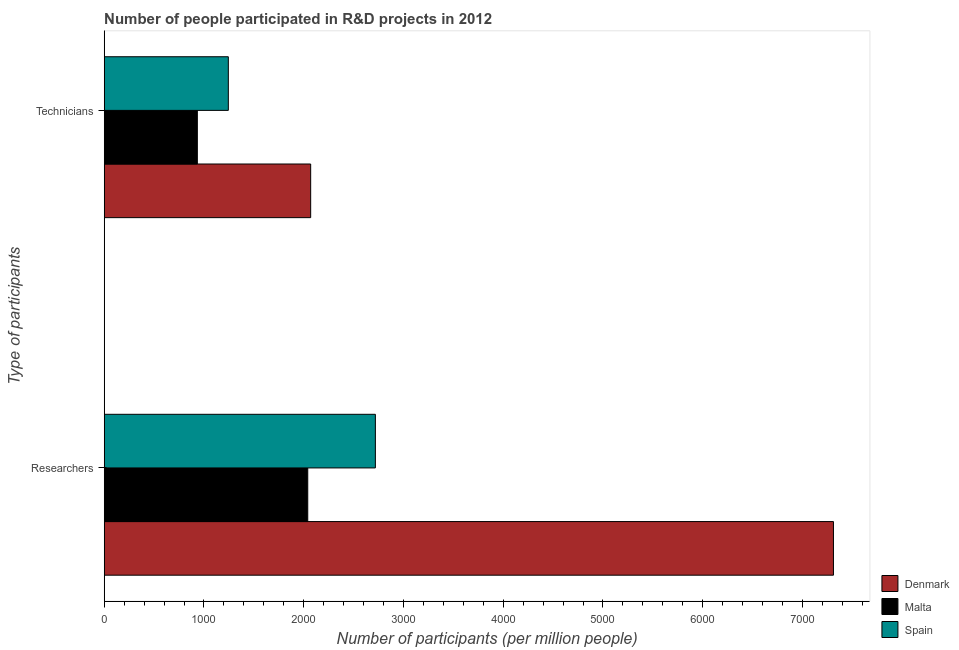How many groups of bars are there?
Offer a terse response. 2. Are the number of bars per tick equal to the number of legend labels?
Give a very brief answer. Yes. How many bars are there on the 1st tick from the bottom?
Give a very brief answer. 3. What is the label of the 2nd group of bars from the top?
Your answer should be compact. Researchers. What is the number of technicians in Spain?
Offer a terse response. 1244.26. Across all countries, what is the maximum number of technicians?
Keep it short and to the point. 2069.7. Across all countries, what is the minimum number of technicians?
Give a very brief answer. 933.6. In which country was the number of technicians maximum?
Your answer should be very brief. Denmark. In which country was the number of researchers minimum?
Keep it short and to the point. Malta. What is the total number of researchers in the graph?
Your answer should be very brief. 1.21e+04. What is the difference between the number of technicians in Spain and that in Malta?
Your answer should be compact. 310.66. What is the difference between the number of researchers in Spain and the number of technicians in Malta?
Offer a terse response. 1784.79. What is the average number of researchers per country?
Your answer should be compact. 4023.11. What is the difference between the number of technicians and number of researchers in Spain?
Keep it short and to the point. -1474.12. In how many countries, is the number of technicians greater than 1400 ?
Your response must be concise. 1. What is the ratio of the number of researchers in Malta to that in Denmark?
Provide a succinct answer. 0.28. What does the 3rd bar from the top in Researchers represents?
Provide a succinct answer. Denmark. What does the 3rd bar from the bottom in Technicians represents?
Provide a short and direct response. Spain. Are all the bars in the graph horizontal?
Provide a succinct answer. Yes. How many countries are there in the graph?
Keep it short and to the point. 3. What is the difference between two consecutive major ticks on the X-axis?
Offer a very short reply. 1000. Does the graph contain grids?
Your answer should be compact. No. Where does the legend appear in the graph?
Ensure brevity in your answer.  Bottom right. How many legend labels are there?
Provide a succinct answer. 3. How are the legend labels stacked?
Offer a very short reply. Vertical. What is the title of the graph?
Give a very brief answer. Number of people participated in R&D projects in 2012. What is the label or title of the X-axis?
Your answer should be compact. Number of participants (per million people). What is the label or title of the Y-axis?
Give a very brief answer. Type of participants. What is the Number of participants (per million people) in Denmark in Researchers?
Provide a short and direct response. 7310.52. What is the Number of participants (per million people) of Malta in Researchers?
Offer a terse response. 2040.44. What is the Number of participants (per million people) in Spain in Researchers?
Make the answer very short. 2718.38. What is the Number of participants (per million people) of Denmark in Technicians?
Give a very brief answer. 2069.7. What is the Number of participants (per million people) of Malta in Technicians?
Give a very brief answer. 933.6. What is the Number of participants (per million people) in Spain in Technicians?
Offer a terse response. 1244.26. Across all Type of participants, what is the maximum Number of participants (per million people) in Denmark?
Provide a short and direct response. 7310.52. Across all Type of participants, what is the maximum Number of participants (per million people) in Malta?
Your answer should be very brief. 2040.44. Across all Type of participants, what is the maximum Number of participants (per million people) in Spain?
Provide a short and direct response. 2718.38. Across all Type of participants, what is the minimum Number of participants (per million people) of Denmark?
Ensure brevity in your answer.  2069.7. Across all Type of participants, what is the minimum Number of participants (per million people) in Malta?
Keep it short and to the point. 933.6. Across all Type of participants, what is the minimum Number of participants (per million people) of Spain?
Offer a very short reply. 1244.26. What is the total Number of participants (per million people) in Denmark in the graph?
Provide a succinct answer. 9380.22. What is the total Number of participants (per million people) of Malta in the graph?
Provide a succinct answer. 2974.04. What is the total Number of participants (per million people) in Spain in the graph?
Your response must be concise. 3962.65. What is the difference between the Number of participants (per million people) in Denmark in Researchers and that in Technicians?
Your answer should be very brief. 5240.81. What is the difference between the Number of participants (per million people) in Malta in Researchers and that in Technicians?
Give a very brief answer. 1106.84. What is the difference between the Number of participants (per million people) in Spain in Researchers and that in Technicians?
Your answer should be very brief. 1474.12. What is the difference between the Number of participants (per million people) in Denmark in Researchers and the Number of participants (per million people) in Malta in Technicians?
Offer a very short reply. 6376.92. What is the difference between the Number of participants (per million people) in Denmark in Researchers and the Number of participants (per million people) in Spain in Technicians?
Provide a succinct answer. 6066.26. What is the difference between the Number of participants (per million people) in Malta in Researchers and the Number of participants (per million people) in Spain in Technicians?
Your answer should be very brief. 796.18. What is the average Number of participants (per million people) in Denmark per Type of participants?
Ensure brevity in your answer.  4690.11. What is the average Number of participants (per million people) in Malta per Type of participants?
Provide a short and direct response. 1487.02. What is the average Number of participants (per million people) in Spain per Type of participants?
Provide a short and direct response. 1981.32. What is the difference between the Number of participants (per million people) in Denmark and Number of participants (per million people) in Malta in Researchers?
Give a very brief answer. 5270.07. What is the difference between the Number of participants (per million people) in Denmark and Number of participants (per million people) in Spain in Researchers?
Offer a terse response. 4592.13. What is the difference between the Number of participants (per million people) in Malta and Number of participants (per million people) in Spain in Researchers?
Your response must be concise. -677.94. What is the difference between the Number of participants (per million people) of Denmark and Number of participants (per million people) of Malta in Technicians?
Keep it short and to the point. 1136.1. What is the difference between the Number of participants (per million people) of Denmark and Number of participants (per million people) of Spain in Technicians?
Your response must be concise. 825.44. What is the difference between the Number of participants (per million people) of Malta and Number of participants (per million people) of Spain in Technicians?
Your answer should be compact. -310.66. What is the ratio of the Number of participants (per million people) of Denmark in Researchers to that in Technicians?
Offer a very short reply. 3.53. What is the ratio of the Number of participants (per million people) of Malta in Researchers to that in Technicians?
Give a very brief answer. 2.19. What is the ratio of the Number of participants (per million people) of Spain in Researchers to that in Technicians?
Provide a succinct answer. 2.18. What is the difference between the highest and the second highest Number of participants (per million people) of Denmark?
Offer a terse response. 5240.81. What is the difference between the highest and the second highest Number of participants (per million people) of Malta?
Make the answer very short. 1106.84. What is the difference between the highest and the second highest Number of participants (per million people) of Spain?
Make the answer very short. 1474.12. What is the difference between the highest and the lowest Number of participants (per million people) in Denmark?
Your answer should be very brief. 5240.81. What is the difference between the highest and the lowest Number of participants (per million people) in Malta?
Your response must be concise. 1106.84. What is the difference between the highest and the lowest Number of participants (per million people) in Spain?
Give a very brief answer. 1474.12. 